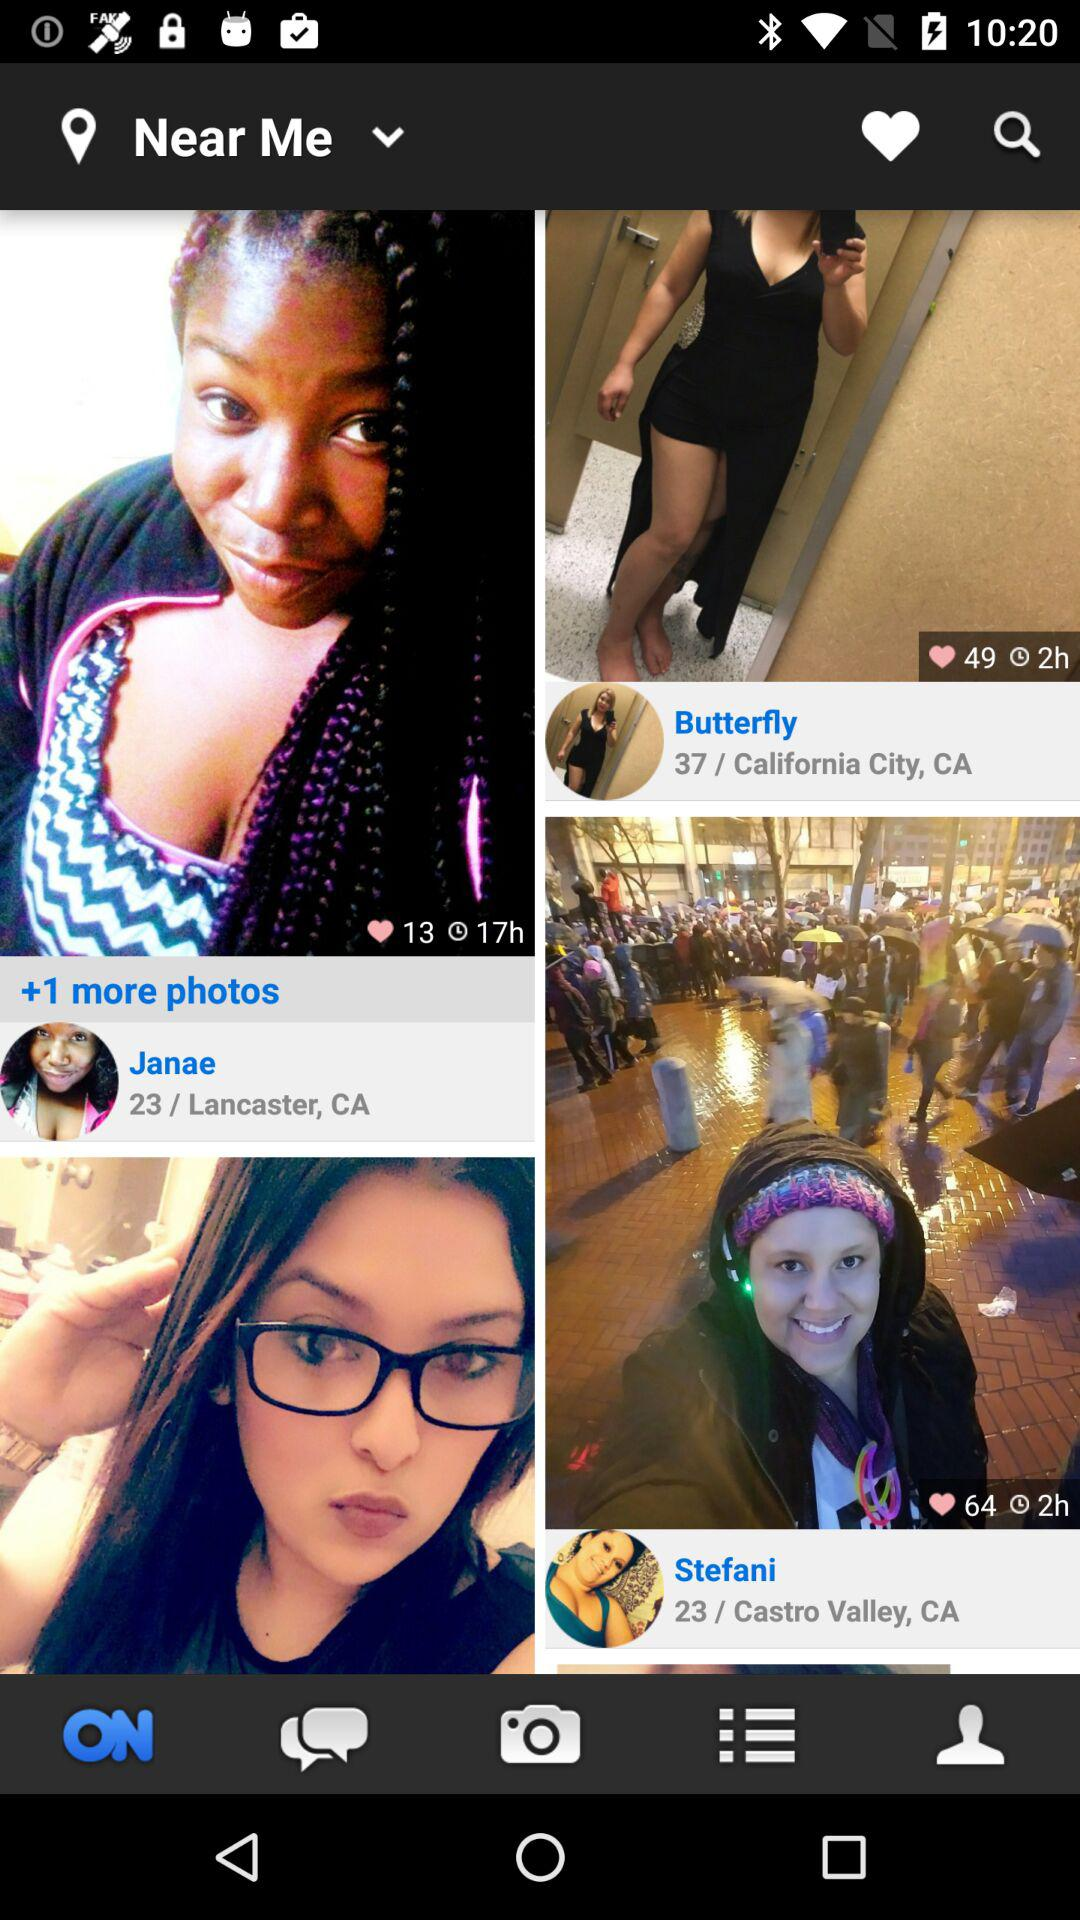What user has the age of 37? The user name is Butterfly. 